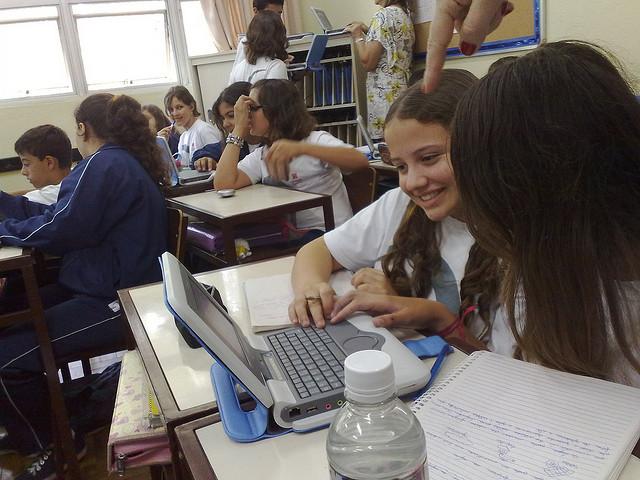Does everyone have a laptop in front of him?
Be succinct. No. Where is this photo taken?
Answer briefly. School. Can you see a bottle of water?
Be succinct. Yes. How many computers are visible?
Quick response, please. 2. 